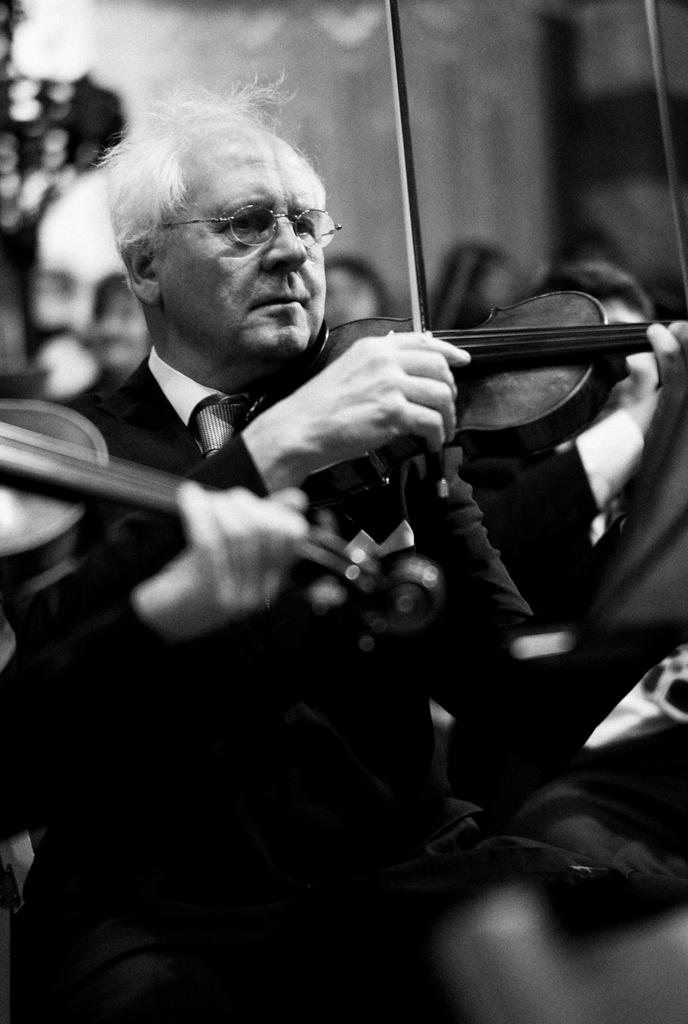What is the man in the image doing? The man is playing the violin. What is the man wearing on his upper body? The man is wearing a black blazer. What is the man's position in the image? The man is sitting. What instrument is the man holding in his hand? The man is holding a violin in his hand. What can be seen on the man's face? The man is wearing spectacles. What is visible in the background of the image? There is a tree and a wall visible in the background of the image. How does the man start the airport in the image? There is no airport present in the image, and the man is not starting anything. He is playing the violin. 